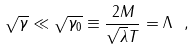Convert formula to latex. <formula><loc_0><loc_0><loc_500><loc_500>\sqrt { \gamma } \ll \sqrt { \gamma _ { 0 } } \equiv \frac { 2 M } { \sqrt { \lambda } T } = \Lambda \ ,</formula> 